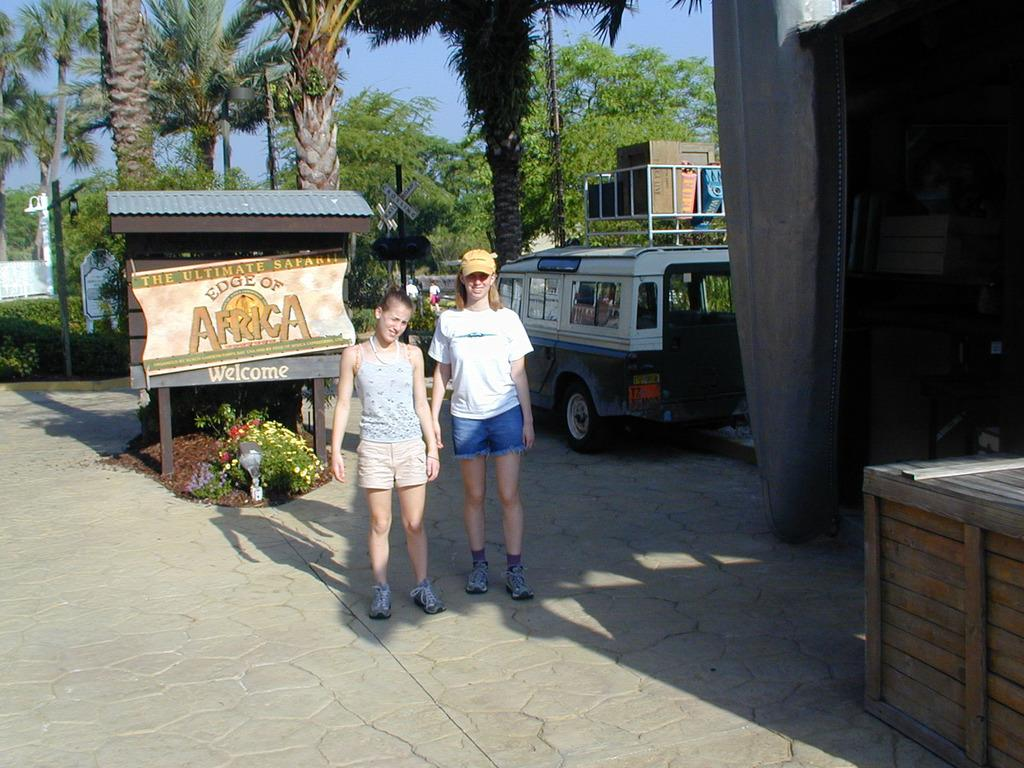<image>
Create a compact narrative representing the image presented. Kids standing in front of a sign that reads The Ultimate Safari The Edge of Africa. 